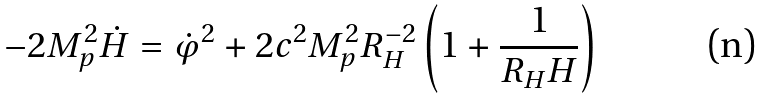Convert formula to latex. <formula><loc_0><loc_0><loc_500><loc_500>- 2 M _ { p } ^ { 2 } \dot { H } = \dot { \varphi } ^ { 2 } + 2 c ^ { 2 } M _ { p } ^ { 2 } R _ { H } ^ { - 2 } \left ( 1 + \frac { 1 } { R _ { H } H } \right )</formula> 